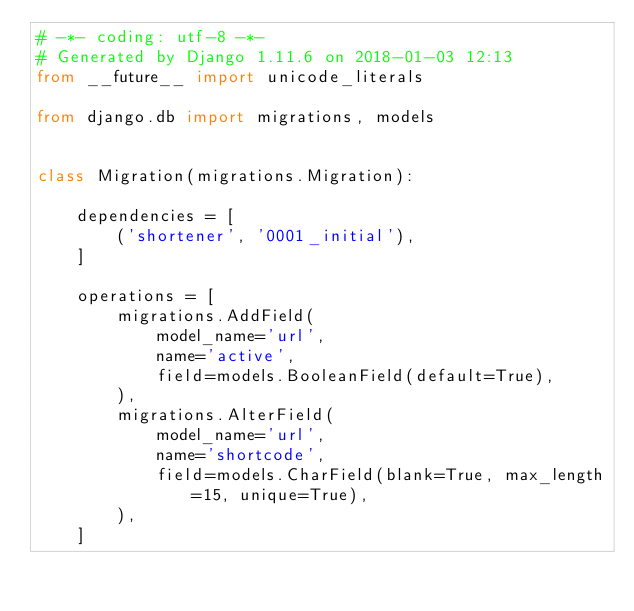<code> <loc_0><loc_0><loc_500><loc_500><_Python_># -*- coding: utf-8 -*-
# Generated by Django 1.11.6 on 2018-01-03 12:13
from __future__ import unicode_literals

from django.db import migrations, models


class Migration(migrations.Migration):

    dependencies = [
        ('shortener', '0001_initial'),
    ]

    operations = [
        migrations.AddField(
            model_name='url',
            name='active',
            field=models.BooleanField(default=True),
        ),
        migrations.AlterField(
            model_name='url',
            name='shortcode',
            field=models.CharField(blank=True, max_length=15, unique=True),
        ),
    ]
</code> 